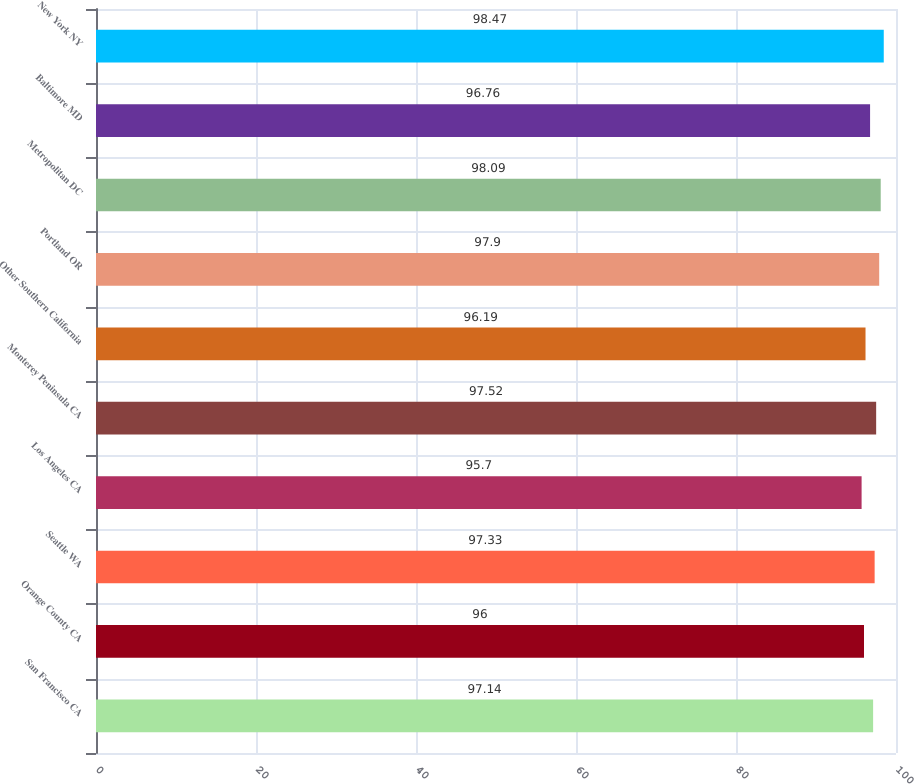Convert chart to OTSL. <chart><loc_0><loc_0><loc_500><loc_500><bar_chart><fcel>San Francisco CA<fcel>Orange County CA<fcel>Seattle WA<fcel>Los Angeles CA<fcel>Monterey Peninsula CA<fcel>Other Southern California<fcel>Portland OR<fcel>Metropolitan DC<fcel>Baltimore MD<fcel>New York NY<nl><fcel>97.14<fcel>96<fcel>97.33<fcel>95.7<fcel>97.52<fcel>96.19<fcel>97.9<fcel>98.09<fcel>96.76<fcel>98.47<nl></chart> 